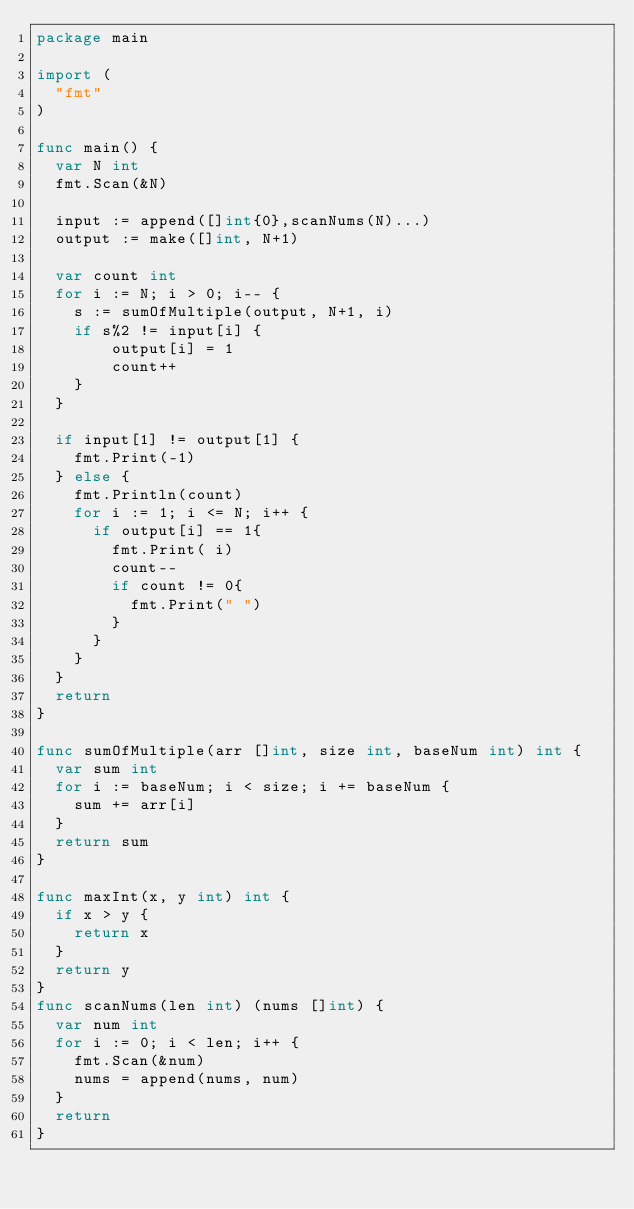<code> <loc_0><loc_0><loc_500><loc_500><_Go_>package main

import (
	"fmt"
)

func main() {
	var N int
	fmt.Scan(&N)

	input := append([]int{0},scanNums(N)...)
	output := make([]int, N+1)

	var count int
	for i := N; i > 0; i-- {
		s := sumOfMultiple(output, N+1, i)
		if s%2 != input[i] {
				output[i] = 1
				count++
		}
	}

	if input[1] != output[1] {
		fmt.Print(-1)
	} else {
		fmt.Println(count)
		for i := 1; i <= N; i++ {
			if output[i] == 1{
				fmt.Print( i)
				count--
				if count != 0{
					fmt.Print(" ")
				}
			}
		}
	}
	return
}

func sumOfMultiple(arr []int, size int, baseNum int) int {
	var sum int
	for i := baseNum; i < size; i += baseNum {
		sum += arr[i]
	}
	return sum
}

func maxInt(x, y int) int {
	if x > y {
		return x
	}
	return y
}
func scanNums(len int) (nums []int) {
	var num int
	for i := 0; i < len; i++ {
		fmt.Scan(&num)
		nums = append(nums, num)
	}
	return
}
</code> 